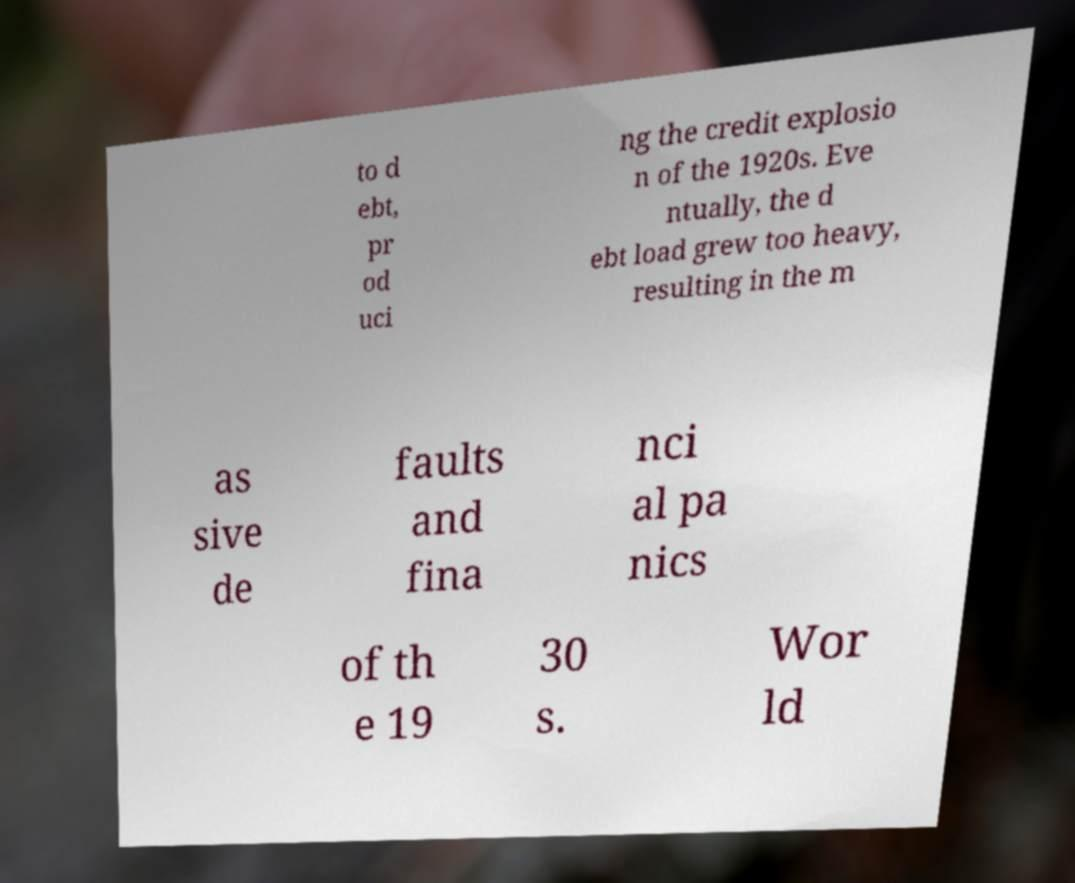For documentation purposes, I need the text within this image transcribed. Could you provide that? to d ebt, pr od uci ng the credit explosio n of the 1920s. Eve ntually, the d ebt load grew too heavy, resulting in the m as sive de faults and fina nci al pa nics of th e 19 30 s. Wor ld 